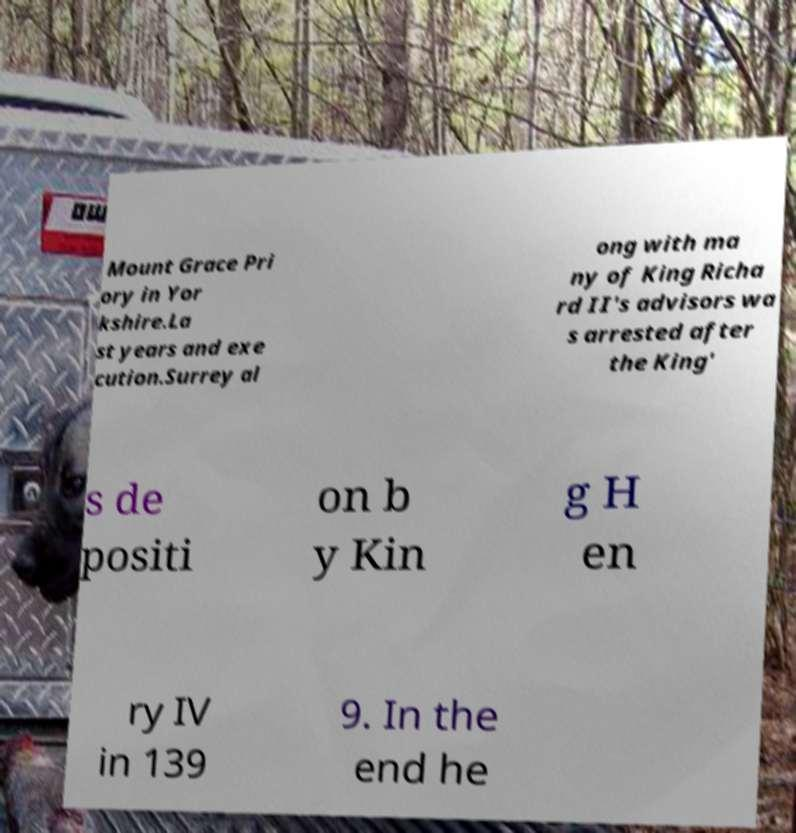Please read and relay the text visible in this image. What does it say? Mount Grace Pri ory in Yor kshire.La st years and exe cution.Surrey al ong with ma ny of King Richa rd II's advisors wa s arrested after the King' s de positi on b y Kin g H en ry IV in 139 9. In the end he 